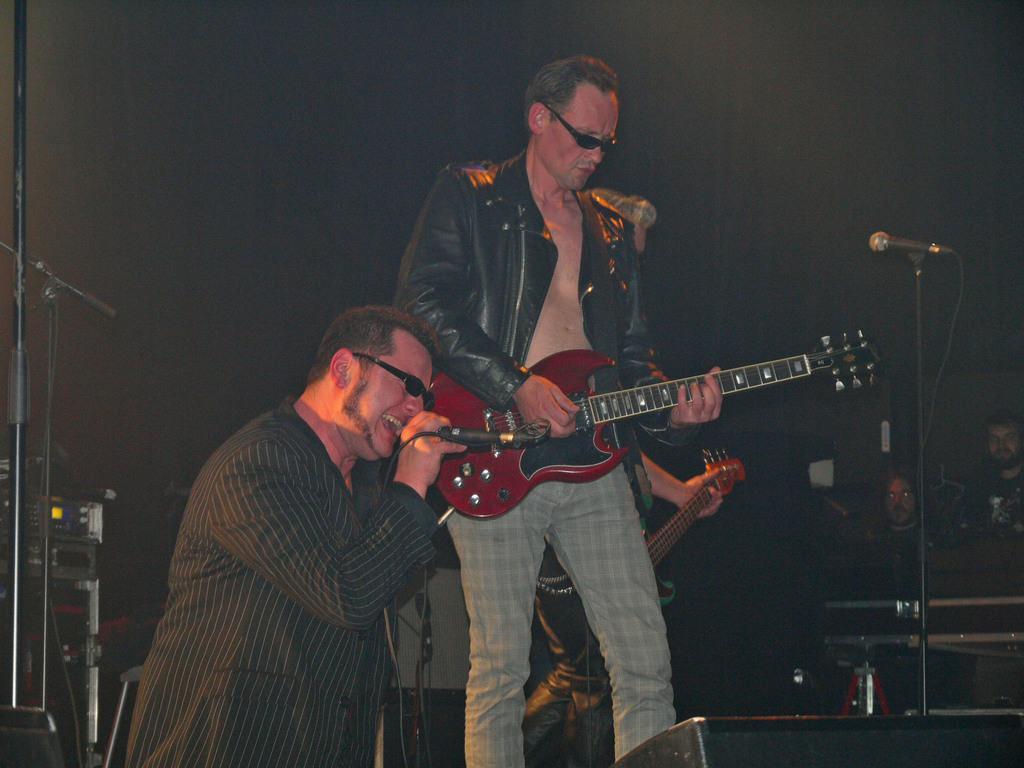Please provide a concise description of this image. There are two people standing. One person is playing guitar and the other person is singing a song. This is the mic attached to the mike stand. Here I can find person hand holding the musical instrument. At background I can see two people. this look like some electronic devices which is kept aside. This looks like a speaker which is black in color. 